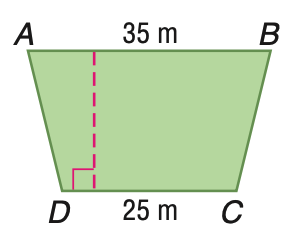Answer the mathemtical geometry problem and directly provide the correct option letter.
Question: Trapezoid A B C D has an area of 750 square meters. Find the height of A B C D.
Choices: A: 20 B: 25 C: 30 D: 35 B 